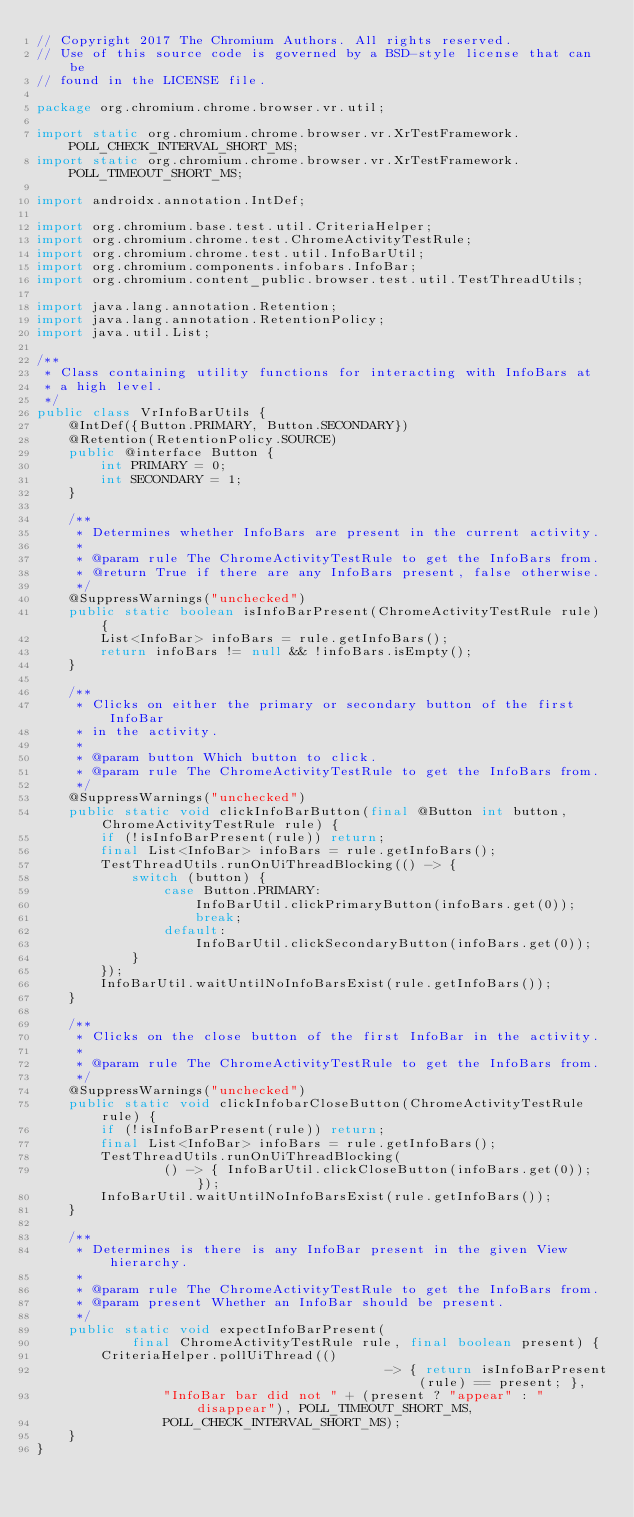Convert code to text. <code><loc_0><loc_0><loc_500><loc_500><_Java_>// Copyright 2017 The Chromium Authors. All rights reserved.
// Use of this source code is governed by a BSD-style license that can be
// found in the LICENSE file.

package org.chromium.chrome.browser.vr.util;

import static org.chromium.chrome.browser.vr.XrTestFramework.POLL_CHECK_INTERVAL_SHORT_MS;
import static org.chromium.chrome.browser.vr.XrTestFramework.POLL_TIMEOUT_SHORT_MS;

import androidx.annotation.IntDef;

import org.chromium.base.test.util.CriteriaHelper;
import org.chromium.chrome.test.ChromeActivityTestRule;
import org.chromium.chrome.test.util.InfoBarUtil;
import org.chromium.components.infobars.InfoBar;
import org.chromium.content_public.browser.test.util.TestThreadUtils;

import java.lang.annotation.Retention;
import java.lang.annotation.RetentionPolicy;
import java.util.List;

/**
 * Class containing utility functions for interacting with InfoBars at
 * a high level.
 */
public class VrInfoBarUtils {
    @IntDef({Button.PRIMARY, Button.SECONDARY})
    @Retention(RetentionPolicy.SOURCE)
    public @interface Button {
        int PRIMARY = 0;
        int SECONDARY = 1;
    }

    /**
     * Determines whether InfoBars are present in the current activity.
     *
     * @param rule The ChromeActivityTestRule to get the InfoBars from.
     * @return True if there are any InfoBars present, false otherwise.
     */
    @SuppressWarnings("unchecked")
    public static boolean isInfoBarPresent(ChromeActivityTestRule rule) {
        List<InfoBar> infoBars = rule.getInfoBars();
        return infoBars != null && !infoBars.isEmpty();
    }

    /**
     * Clicks on either the primary or secondary button of the first InfoBar
     * in the activity.
     *
     * @param button Which button to click.
     * @param rule The ChromeActivityTestRule to get the InfoBars from.
     */
    @SuppressWarnings("unchecked")
    public static void clickInfoBarButton(final @Button int button, ChromeActivityTestRule rule) {
        if (!isInfoBarPresent(rule)) return;
        final List<InfoBar> infoBars = rule.getInfoBars();
        TestThreadUtils.runOnUiThreadBlocking(() -> {
            switch (button) {
                case Button.PRIMARY:
                    InfoBarUtil.clickPrimaryButton(infoBars.get(0));
                    break;
                default:
                    InfoBarUtil.clickSecondaryButton(infoBars.get(0));
            }
        });
        InfoBarUtil.waitUntilNoInfoBarsExist(rule.getInfoBars());
    }

    /**
     * Clicks on the close button of the first InfoBar in the activity.
     *
     * @param rule The ChromeActivityTestRule to get the InfoBars from.
     */
    @SuppressWarnings("unchecked")
    public static void clickInfobarCloseButton(ChromeActivityTestRule rule) {
        if (!isInfoBarPresent(rule)) return;
        final List<InfoBar> infoBars = rule.getInfoBars();
        TestThreadUtils.runOnUiThreadBlocking(
                () -> { InfoBarUtil.clickCloseButton(infoBars.get(0)); });
        InfoBarUtil.waitUntilNoInfoBarsExist(rule.getInfoBars());
    }

    /**
     * Determines is there is any InfoBar present in the given View hierarchy.
     *
     * @param rule The ChromeActivityTestRule to get the InfoBars from.
     * @param present Whether an InfoBar should be present.
     */
    public static void expectInfoBarPresent(
            final ChromeActivityTestRule rule, final boolean present) {
        CriteriaHelper.pollUiThread(()
                                            -> { return isInfoBarPresent(rule) == present; },
                "InfoBar bar did not " + (present ? "appear" : "disappear"), POLL_TIMEOUT_SHORT_MS,
                POLL_CHECK_INTERVAL_SHORT_MS);
    }
}
</code> 